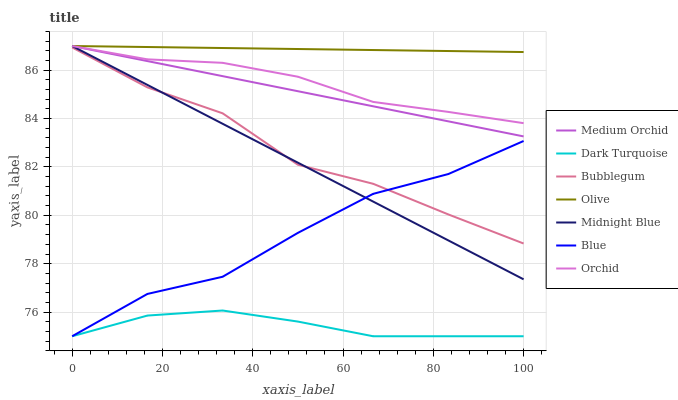Does Dark Turquoise have the minimum area under the curve?
Answer yes or no. Yes. Does Olive have the maximum area under the curve?
Answer yes or no. Yes. Does Midnight Blue have the minimum area under the curve?
Answer yes or no. No. Does Midnight Blue have the maximum area under the curve?
Answer yes or no. No. Is Olive the smoothest?
Answer yes or no. Yes. Is Blue the roughest?
Answer yes or no. Yes. Is Midnight Blue the smoothest?
Answer yes or no. No. Is Midnight Blue the roughest?
Answer yes or no. No. Does Blue have the lowest value?
Answer yes or no. Yes. Does Midnight Blue have the lowest value?
Answer yes or no. No. Does Orchid have the highest value?
Answer yes or no. Yes. Does Dark Turquoise have the highest value?
Answer yes or no. No. Is Dark Turquoise less than Midnight Blue?
Answer yes or no. Yes. Is Olive greater than Dark Turquoise?
Answer yes or no. Yes. Does Midnight Blue intersect Bubblegum?
Answer yes or no. Yes. Is Midnight Blue less than Bubblegum?
Answer yes or no. No. Is Midnight Blue greater than Bubblegum?
Answer yes or no. No. Does Dark Turquoise intersect Midnight Blue?
Answer yes or no. No. 